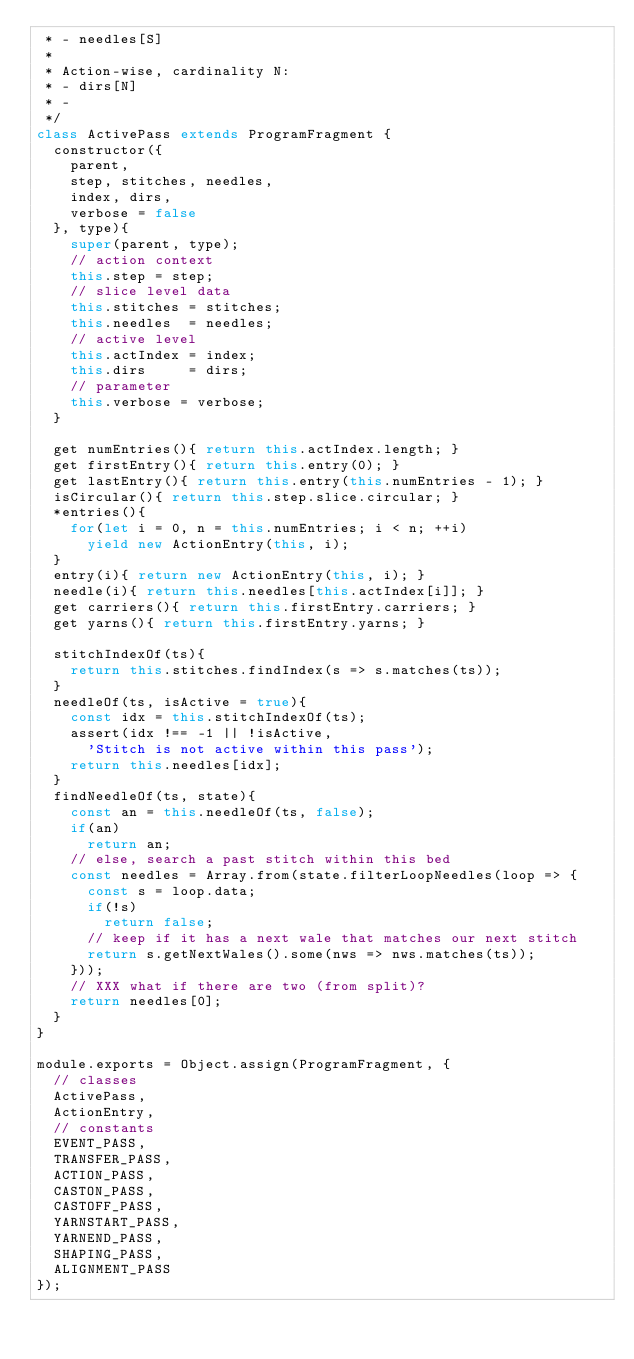Convert code to text. <code><loc_0><loc_0><loc_500><loc_500><_JavaScript_> * - needles[S]
 * 
 * Action-wise, cardinality N:
 * - dirs[N]
 * - 
 */
class ActivePass extends ProgramFragment {
  constructor({
    parent,
    step, stitches, needles,
    index, dirs,
    verbose = false
  }, type){
    super(parent, type);
    // action context
    this.step = step;
    // slice level data
    this.stitches = stitches;
    this.needles  = needles;
    // active level
    this.actIndex = index;
    this.dirs     = dirs;
    // parameter
    this.verbose = verbose;
  }

  get numEntries(){ return this.actIndex.length; }
  get firstEntry(){ return this.entry(0); }
  get lastEntry(){ return this.entry(this.numEntries - 1); }
  isCircular(){ return this.step.slice.circular; }
  *entries(){
    for(let i = 0, n = this.numEntries; i < n; ++i)
      yield new ActionEntry(this, i);
  }
  entry(i){ return new ActionEntry(this, i); }
  needle(i){ return this.needles[this.actIndex[i]]; }
  get carriers(){ return this.firstEntry.carriers; }
  get yarns(){ return this.firstEntry.yarns; }

  stitchIndexOf(ts){
    return this.stitches.findIndex(s => s.matches(ts));
  }
  needleOf(ts, isActive = true){
    const idx = this.stitchIndexOf(ts);
    assert(idx !== -1 || !isActive,
      'Stitch is not active within this pass');
    return this.needles[idx];
  }
  findNeedleOf(ts, state){
    const an = this.needleOf(ts, false);
    if(an)
      return an;
    // else, search a past stitch within this bed
    const needles = Array.from(state.filterLoopNeedles(loop => {
      const s = loop.data;
      if(!s)
        return false;
      // keep if it has a next wale that matches our next stitch
      return s.getNextWales().some(nws => nws.matches(ts));
    }));
    // XXX what if there are two (from split)?
    return needles[0];
  }
}

module.exports = Object.assign(ProgramFragment, {
  // classes
  ActivePass,
  ActionEntry,
  // constants
  EVENT_PASS,
  TRANSFER_PASS,
  ACTION_PASS,
  CASTON_PASS,
  CASTOFF_PASS,
  YARNSTART_PASS,
  YARNEND_PASS,
  SHAPING_PASS,
  ALIGNMENT_PASS
});</code> 